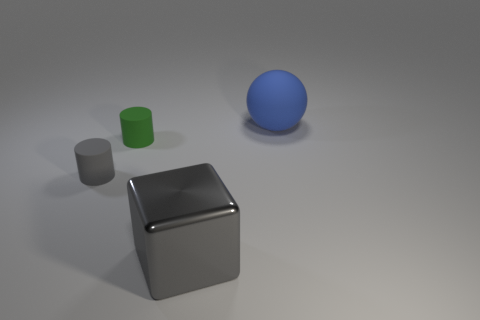Add 3 small green rubber cylinders. How many objects exist? 7 Subtract all spheres. How many objects are left? 3 Subtract all matte balls. Subtract all yellow cubes. How many objects are left? 3 Add 4 blue things. How many blue things are left? 5 Add 4 small gray objects. How many small gray objects exist? 5 Subtract 0 red cylinders. How many objects are left? 4 